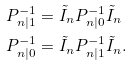Convert formula to latex. <formula><loc_0><loc_0><loc_500><loc_500>P _ { n | 1 } ^ { - 1 } & = \tilde { I } _ { n } P _ { n | 0 } ^ { - 1 } \tilde { I } _ { n } \\ P _ { n | 0 } ^ { - 1 } & = \tilde { I } _ { n } P _ { n | 1 } ^ { - 1 } \tilde { I } _ { n } .</formula> 